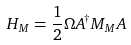<formula> <loc_0><loc_0><loc_500><loc_500>H _ { M } = \frac { 1 } { 2 } \Omega A ^ { \dagger } M _ { M } A</formula> 